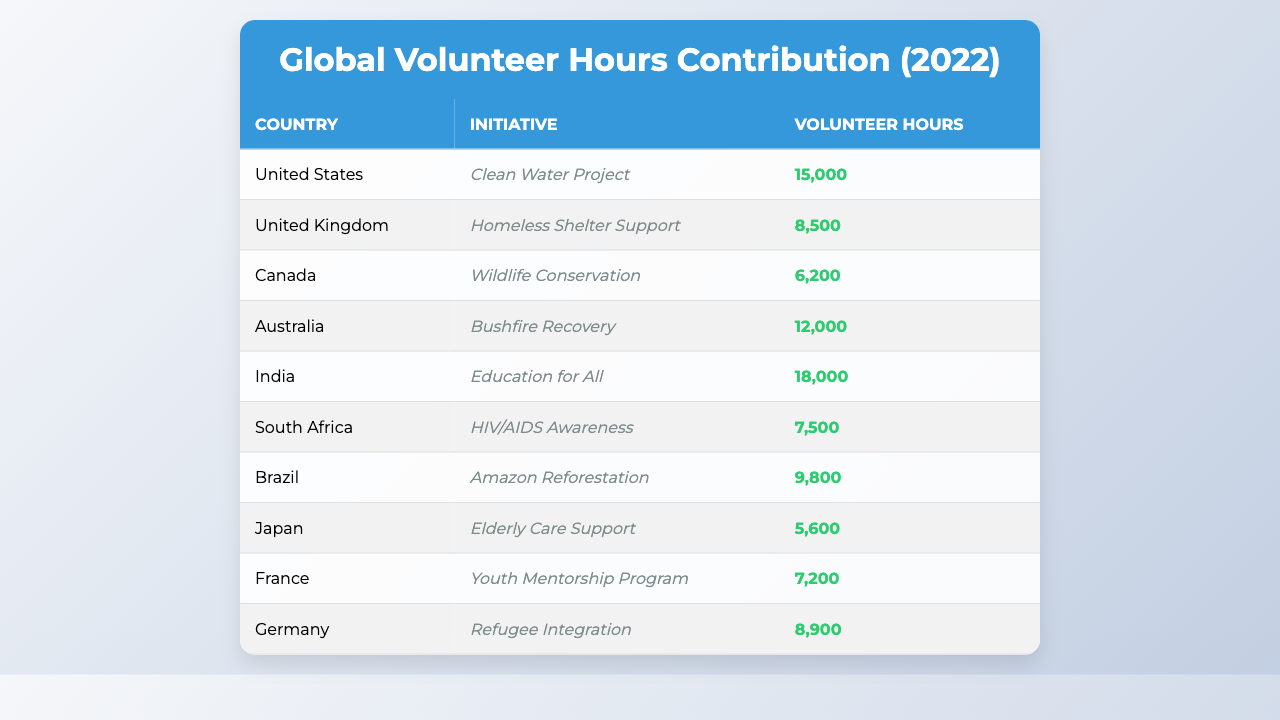What country had the highest volunteer hours contributed? The table indicates that India had the most volunteer hours contributed at 18,000 hours for the "Education for All" initiative in 2022.
Answer: India Which initiative in the United States had the most volunteer hours? The "Clean Water Project" in the United States had 15,000 volunteer hours contributed in 2022, which is the highest among initiatives in that country.
Answer: Clean Water Project How many total volunteer hours were contributed across all initiatives in 2022? Summing all volunteer hours: 15,000 + 8,500 + 6,200 + 12,000 + 18,000 + 7,500 + 9,800 + 5,600 + 7,200 + 8,900 = 89,700 hours contributed overall in 2022.
Answer: 89,700 Did Brazil's volunteer hours exceed those in Japan? Brazil had 9,800 volunteer hours which is higher than Japan's 5,600 volunteer hours as indicated in the table. Therefore, the statement is true.
Answer: Yes What is the average number of volunteer hours contributed from the countries listed? The total hours are 89,700, and there are 10 countries. Dividing total hours by the number of countries gives an average of 89,700 / 10 = 8,970 volunteer hours per country.
Answer: 8,970 Is the volunteer contribution for the "Elderly Care Support" initiative higher than the lowest contribution in the table? The "Elderly Care Support" initiative in Japan contributed 5,600 hours, which is higher than the lowest contribution of 6,200 hours from Canada for "Wildlife Conservation." Therefore, the statement is false.
Answer: No Which two countries contributed the least volunteer hours combined? Canada and Japan contributed 6,200 and 5,600 hours respectively. Adding them gives a combined total of 6,200 + 5,600 = 11,800 volunteer hours, making it the least combined contribution.
Answer: 11,800 How many more volunteer hours did India contribute compared to the United Kingdom? India contributed 18,000 hours, while the United Kingdom contributed 8,500 hours. The difference is 18,000 - 8,500 = 9,500 hours.
Answer: 9,500 What percentage of the total volunteer hours did Australia contribute? Australia's contribution was 12,000 hours. To find the percentage: (12,000 / 89,700) * 100 = 13.39%. So, Australia contributed approximately 13.39% of the total hours.
Answer: 13.39% Which initiative had the fewest volunteer hours, and how many were contributed? The initiative with the fewest volunteer hours is "Elderly Care Support" in Japan, which had 5,600 hours contributed in 2022.
Answer: Elderly Care Support, 5,600 